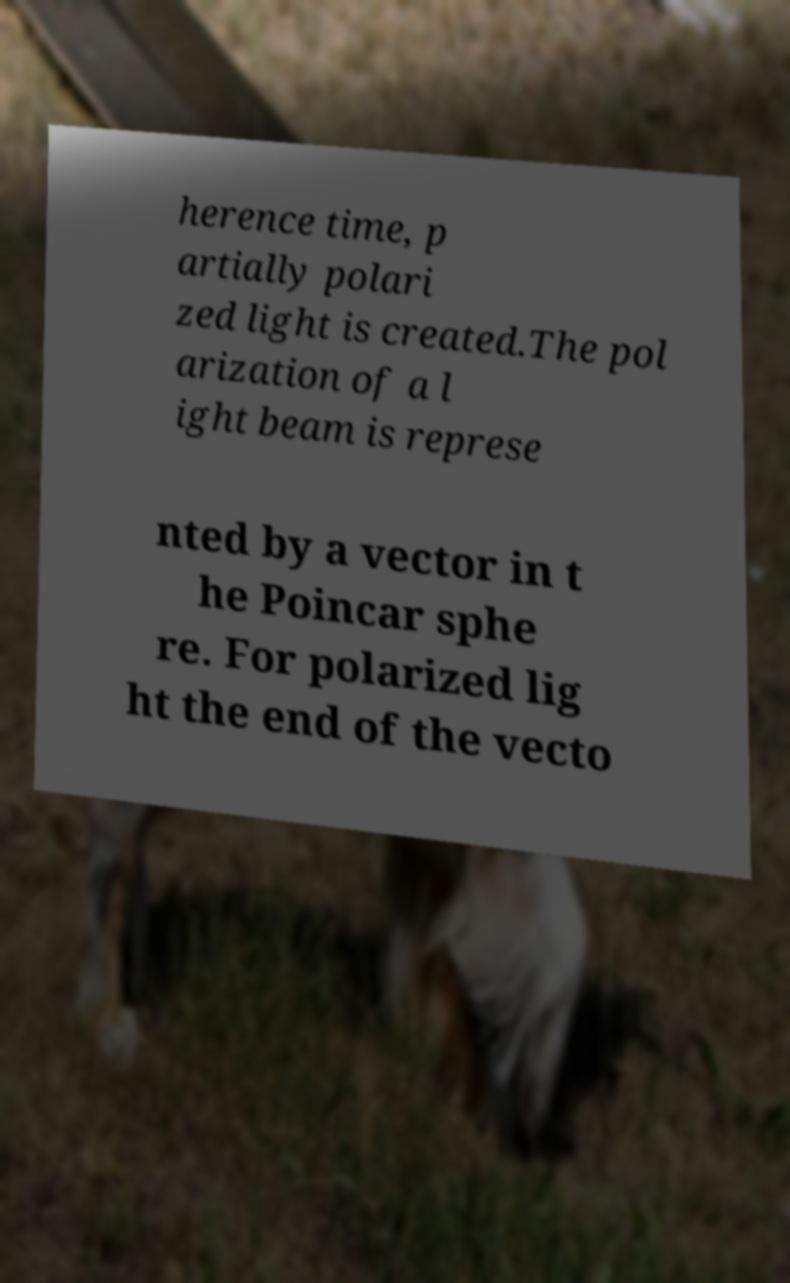What messages or text are displayed in this image? I need them in a readable, typed format. herence time, p artially polari zed light is created.The pol arization of a l ight beam is represe nted by a vector in t he Poincar sphe re. For polarized lig ht the end of the vecto 